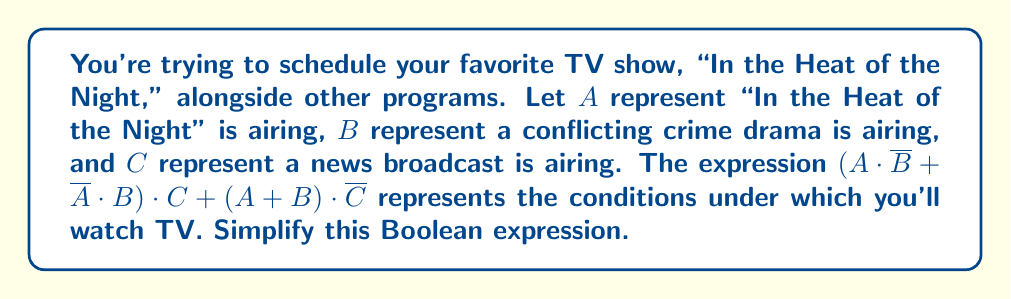Can you solve this math problem? Let's simplify this expression step by step:

1) First, let's focus on $(A \cdot \overline{B} + \overline{A} \cdot B)$:
   This is the exclusive OR (XOR) of $A$ and $B$, which we can write as $A \oplus B$.

2) Now our expression looks like: $(A \oplus B) \cdot C + (A + B) \cdot \overline{C}$

3) Let's distribute $C$ and $\overline{C}$:
   $$(A \oplus B) \cdot C + A \cdot \overline{C} + B \cdot \overline{C}$$

4) Expand $A \oplus B$:
   $$(A \cdot \overline{B} + \overline{A} \cdot B) \cdot C + A \cdot \overline{C} + B \cdot \overline{C}$$

5) Distribute $C$:
   $$A \cdot \overline{B} \cdot C + \overline{A} \cdot B \cdot C + A \cdot \overline{C} + B \cdot \overline{C}$$

6) Group terms with $A$ and terms with $B$:
   $$(A \cdot \overline{B} \cdot C + A \cdot \overline{C}) + (\overline{A} \cdot B \cdot C + B \cdot \overline{C})$$

7) Factor out $A$ and $B$:
   $$A \cdot (\overline{B} \cdot C + \overline{C}) + B \cdot (\overline{A} \cdot C + \overline{C})$$

8) Simplify $\overline{B} \cdot C + \overline{C} = C + \overline{C} = 1$ (similarly for $\overline{A} \cdot C + \overline{C}$):
   $$A \cdot 1 + B \cdot 1$$

9) Final simplification:
   $$A + B$$
Answer: $A + B$ 